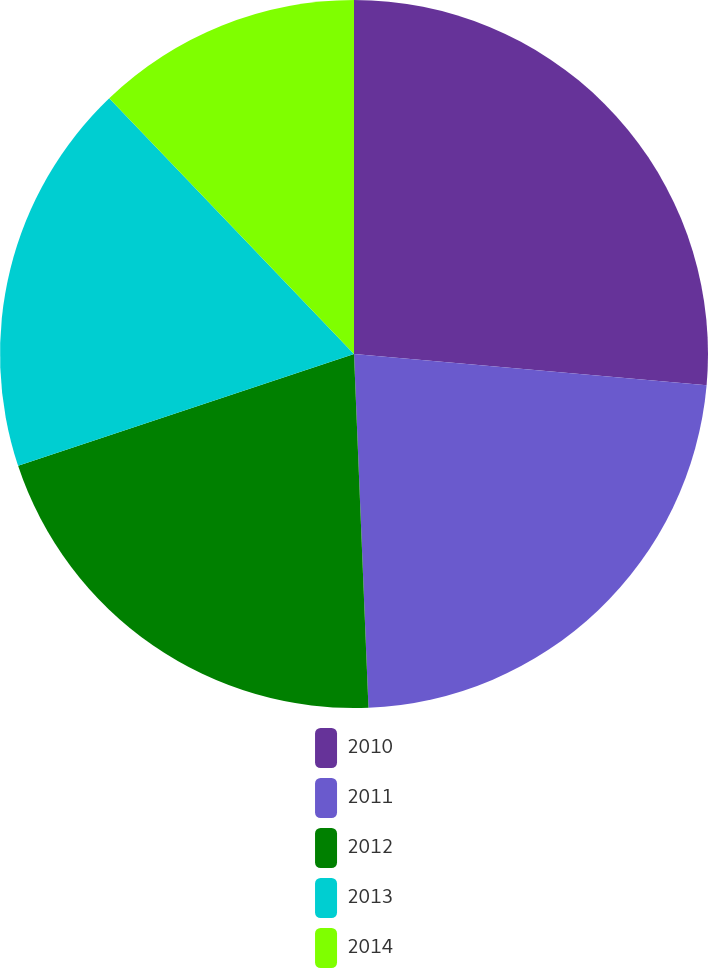Convert chart to OTSL. <chart><loc_0><loc_0><loc_500><loc_500><pie_chart><fcel>2010<fcel>2011<fcel>2012<fcel>2013<fcel>2014<nl><fcel>26.41%<fcel>22.94%<fcel>20.54%<fcel>17.96%<fcel>12.15%<nl></chart> 